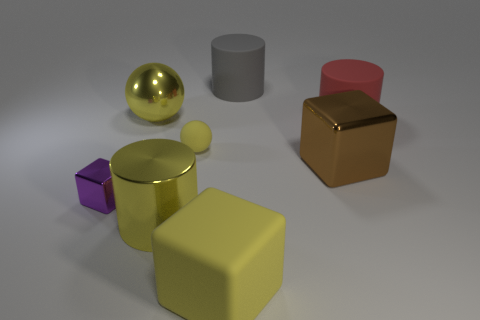Are there any purple metallic objects?
Give a very brief answer. Yes. There is a metallic cube on the right side of the big yellow object behind the yellow metal thing in front of the small block; what is its color?
Your answer should be compact. Brown. There is a big block behind the big yellow cylinder; is there a gray matte thing that is in front of it?
Your answer should be very brief. No. There is a rubber thing that is in front of the brown metallic object; does it have the same color as the rubber thing to the right of the large gray cylinder?
Your answer should be compact. No. How many red matte cylinders have the same size as the purple object?
Your response must be concise. 0. There is a matte cylinder right of the gray cylinder; does it have the same size as the large brown object?
Ensure brevity in your answer.  Yes. What is the shape of the large red matte object?
Offer a terse response. Cylinder. The matte object that is the same color as the tiny ball is what size?
Provide a succinct answer. Large. Is the material of the block in front of the tiny cube the same as the small sphere?
Give a very brief answer. Yes. Is there another big rubber block of the same color as the large rubber block?
Provide a short and direct response. No. 